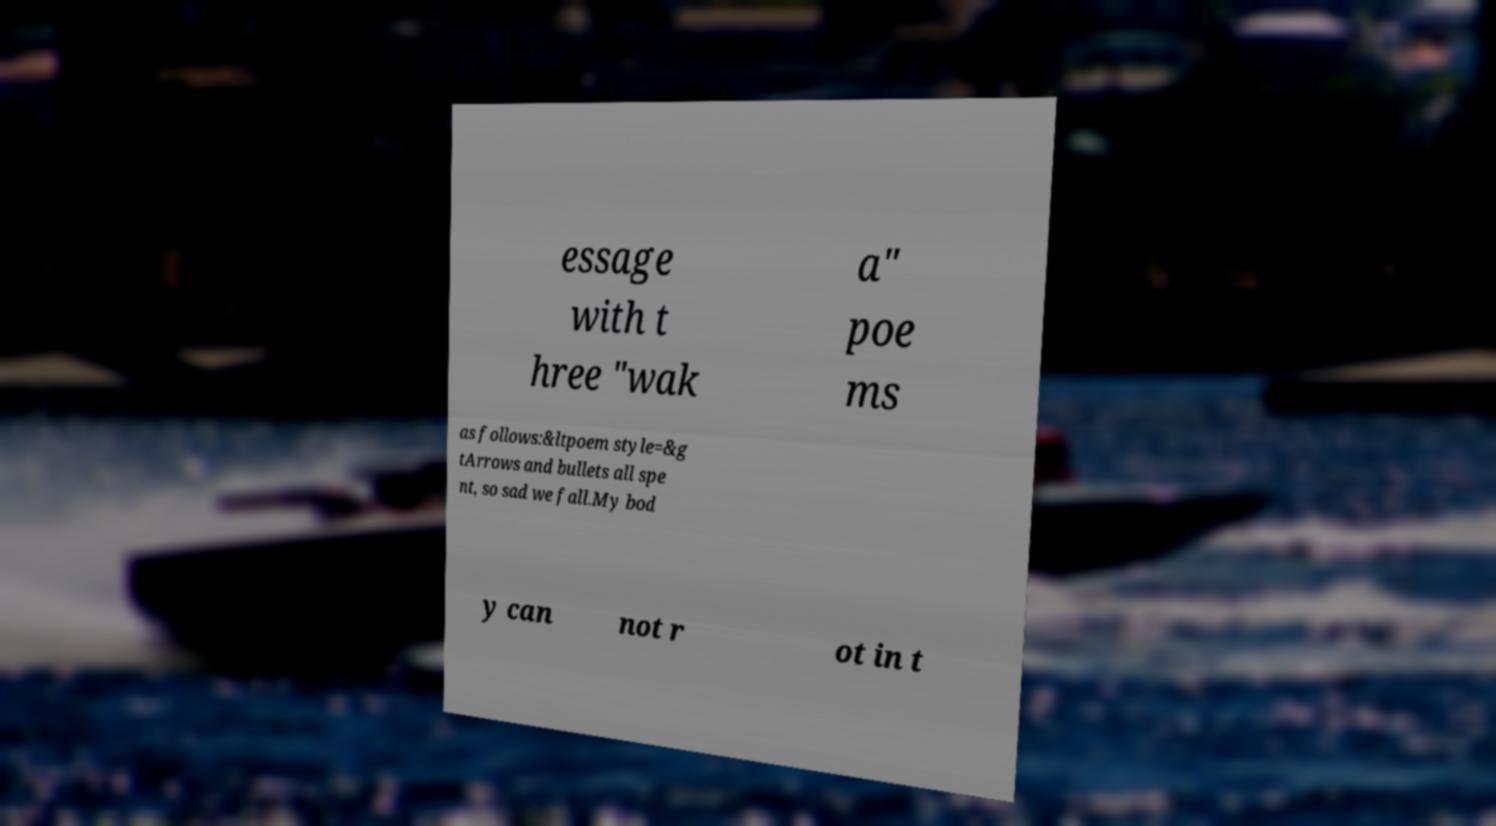I need the written content from this picture converted into text. Can you do that? essage with t hree "wak a" poe ms as follows:&ltpoem style=&g tArrows and bullets all spe nt, so sad we fall.My bod y can not r ot in t 